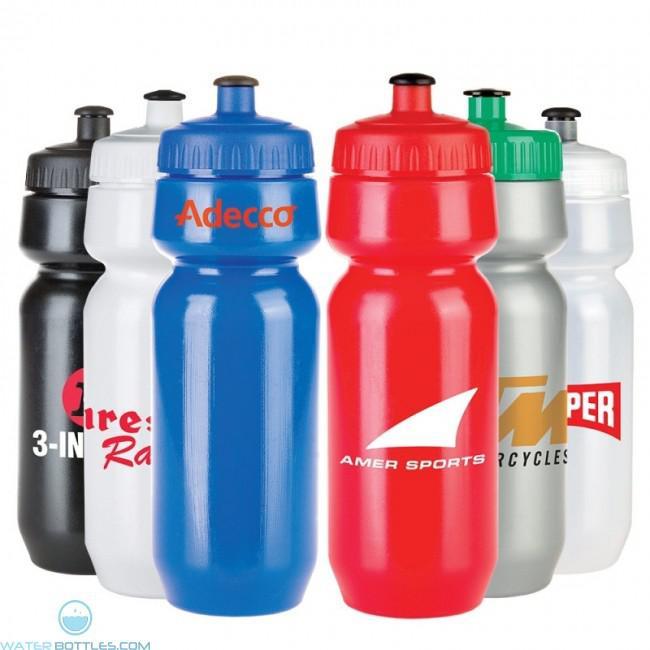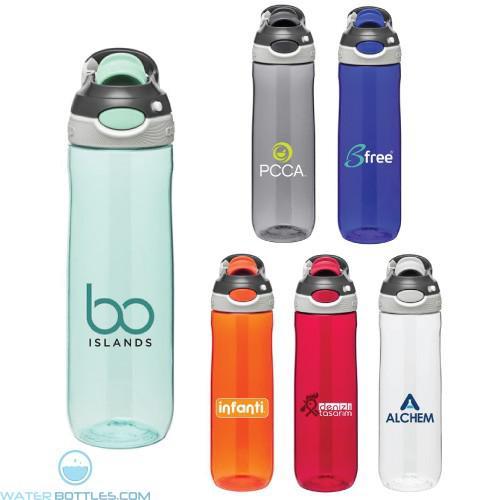The first image is the image on the left, the second image is the image on the right. For the images shown, is this caption "Five identical water bottles are in a V-formation in the image on the left." true? Answer yes or no. No. The first image is the image on the left, the second image is the image on the right. Evaluate the accuracy of this statement regarding the images: "The left image shows 5 water bottles lined up in V-formation with the words, """"clear water"""" on them.". Is it true? Answer yes or no. No. 